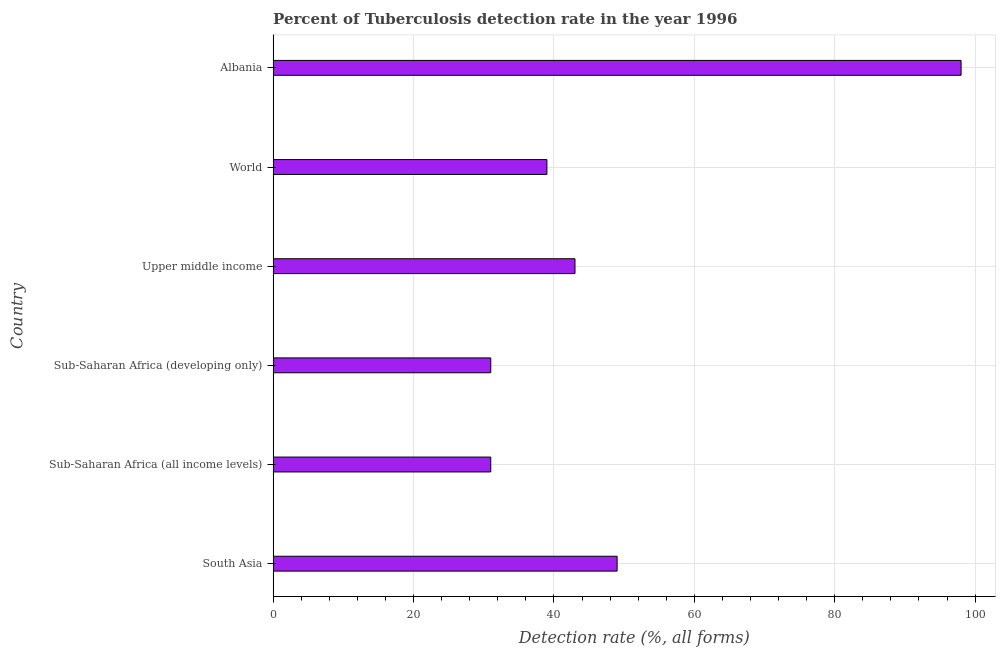What is the title of the graph?
Provide a short and direct response. Percent of Tuberculosis detection rate in the year 1996. What is the label or title of the X-axis?
Provide a short and direct response. Detection rate (%, all forms). What is the label or title of the Y-axis?
Provide a succinct answer. Country. What is the detection rate of tuberculosis in World?
Make the answer very short. 39. In which country was the detection rate of tuberculosis maximum?
Give a very brief answer. Albania. In which country was the detection rate of tuberculosis minimum?
Provide a succinct answer. Sub-Saharan Africa (all income levels). What is the sum of the detection rate of tuberculosis?
Keep it short and to the point. 291. What is the difference between the detection rate of tuberculosis in Sub-Saharan Africa (all income levels) and Sub-Saharan Africa (developing only)?
Make the answer very short. 0. What is the average detection rate of tuberculosis per country?
Your response must be concise. 48.5. In how many countries, is the detection rate of tuberculosis greater than 24 %?
Provide a short and direct response. 6. What is the ratio of the detection rate of tuberculosis in South Asia to that in World?
Offer a terse response. 1.26. What is the difference between the highest and the second highest detection rate of tuberculosis?
Ensure brevity in your answer.  49. Is the sum of the detection rate of tuberculosis in South Asia and Sub-Saharan Africa (developing only) greater than the maximum detection rate of tuberculosis across all countries?
Offer a terse response. No. What is the difference between the highest and the lowest detection rate of tuberculosis?
Make the answer very short. 67. How many countries are there in the graph?
Make the answer very short. 6. What is the difference between two consecutive major ticks on the X-axis?
Offer a very short reply. 20. Are the values on the major ticks of X-axis written in scientific E-notation?
Offer a very short reply. No. What is the Detection rate (%, all forms) of South Asia?
Offer a very short reply. 49. What is the Detection rate (%, all forms) of Upper middle income?
Make the answer very short. 43. What is the Detection rate (%, all forms) of Albania?
Your answer should be very brief. 98. What is the difference between the Detection rate (%, all forms) in South Asia and World?
Your answer should be compact. 10. What is the difference between the Detection rate (%, all forms) in South Asia and Albania?
Offer a very short reply. -49. What is the difference between the Detection rate (%, all forms) in Sub-Saharan Africa (all income levels) and Upper middle income?
Offer a terse response. -12. What is the difference between the Detection rate (%, all forms) in Sub-Saharan Africa (all income levels) and World?
Provide a short and direct response. -8. What is the difference between the Detection rate (%, all forms) in Sub-Saharan Africa (all income levels) and Albania?
Give a very brief answer. -67. What is the difference between the Detection rate (%, all forms) in Sub-Saharan Africa (developing only) and World?
Your answer should be very brief. -8. What is the difference between the Detection rate (%, all forms) in Sub-Saharan Africa (developing only) and Albania?
Offer a terse response. -67. What is the difference between the Detection rate (%, all forms) in Upper middle income and World?
Offer a terse response. 4. What is the difference between the Detection rate (%, all forms) in Upper middle income and Albania?
Provide a succinct answer. -55. What is the difference between the Detection rate (%, all forms) in World and Albania?
Your answer should be very brief. -59. What is the ratio of the Detection rate (%, all forms) in South Asia to that in Sub-Saharan Africa (all income levels)?
Make the answer very short. 1.58. What is the ratio of the Detection rate (%, all forms) in South Asia to that in Sub-Saharan Africa (developing only)?
Keep it short and to the point. 1.58. What is the ratio of the Detection rate (%, all forms) in South Asia to that in Upper middle income?
Your answer should be compact. 1.14. What is the ratio of the Detection rate (%, all forms) in South Asia to that in World?
Ensure brevity in your answer.  1.26. What is the ratio of the Detection rate (%, all forms) in Sub-Saharan Africa (all income levels) to that in Upper middle income?
Keep it short and to the point. 0.72. What is the ratio of the Detection rate (%, all forms) in Sub-Saharan Africa (all income levels) to that in World?
Give a very brief answer. 0.8. What is the ratio of the Detection rate (%, all forms) in Sub-Saharan Africa (all income levels) to that in Albania?
Keep it short and to the point. 0.32. What is the ratio of the Detection rate (%, all forms) in Sub-Saharan Africa (developing only) to that in Upper middle income?
Offer a very short reply. 0.72. What is the ratio of the Detection rate (%, all forms) in Sub-Saharan Africa (developing only) to that in World?
Your answer should be compact. 0.8. What is the ratio of the Detection rate (%, all forms) in Sub-Saharan Africa (developing only) to that in Albania?
Make the answer very short. 0.32. What is the ratio of the Detection rate (%, all forms) in Upper middle income to that in World?
Provide a short and direct response. 1.1. What is the ratio of the Detection rate (%, all forms) in Upper middle income to that in Albania?
Provide a succinct answer. 0.44. What is the ratio of the Detection rate (%, all forms) in World to that in Albania?
Your answer should be compact. 0.4. 